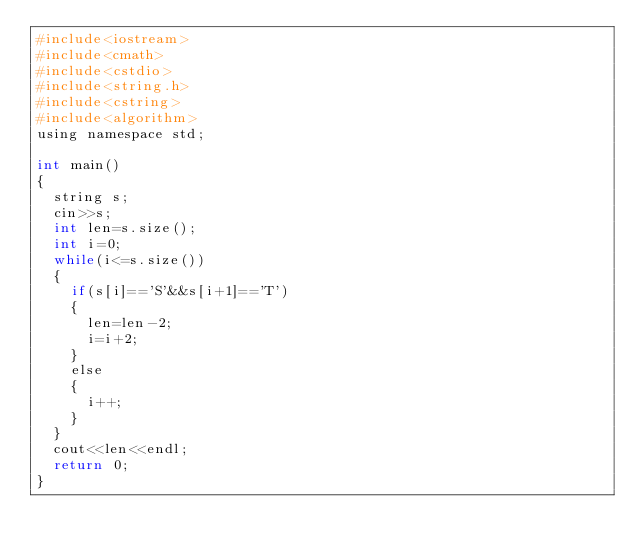<code> <loc_0><loc_0><loc_500><loc_500><_Awk_>#include<iostream>
#include<cmath>
#include<cstdio>
#include<string.h>
#include<cstring>
#include<algorithm>
using namespace std;

int main()
{
	string s;
	cin>>s;
	int len=s.size();
	int i=0;
	while(i<=s.size())
	{
		if(s[i]=='S'&&s[i+1]=='T')
		{
			len=len-2;
			i=i+2;
		}
		else
		{
			i++;
		}
	}
	cout<<len<<endl;
	return 0;
}</code> 